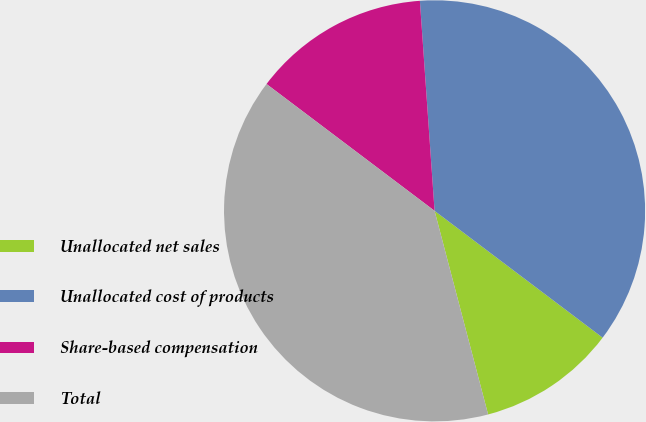Convert chart to OTSL. <chart><loc_0><loc_0><loc_500><loc_500><pie_chart><fcel>Unallocated net sales<fcel>Unallocated cost of products<fcel>Share-based compensation<fcel>Total<nl><fcel>10.62%<fcel>36.4%<fcel>13.6%<fcel>39.38%<nl></chart> 